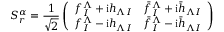Convert formula to latex. <formula><loc_0><loc_0><loc_500><loc_500>S _ { r } ^ { \alpha } = { \frac { 1 } { \sqrt { 2 } } } \left ( \begin{array} { l l } { { f _ { I } ^ { \Lambda } + i h _ { \Lambda I } } } & { { \bar { f } _ { I } ^ { \Lambda } + i \bar { h } _ { \Lambda I } } } \\ { { f _ { I } ^ { \Lambda } - i h _ { \Lambda I } } } & { { \bar { f } _ { I } ^ { \Lambda } - i \bar { h } _ { \Lambda I } } } \end{array} \right )</formula> 